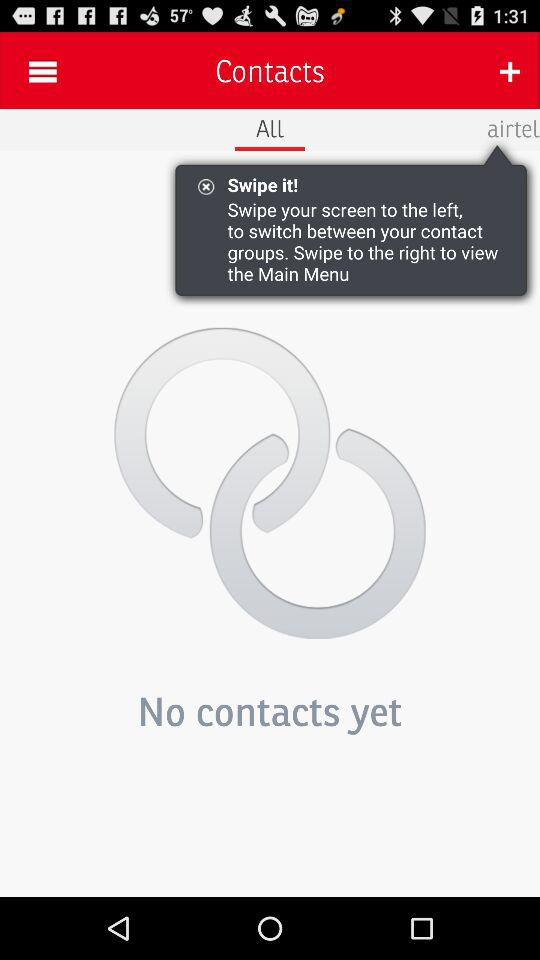Which tab is selected? The selected tab is "All". 